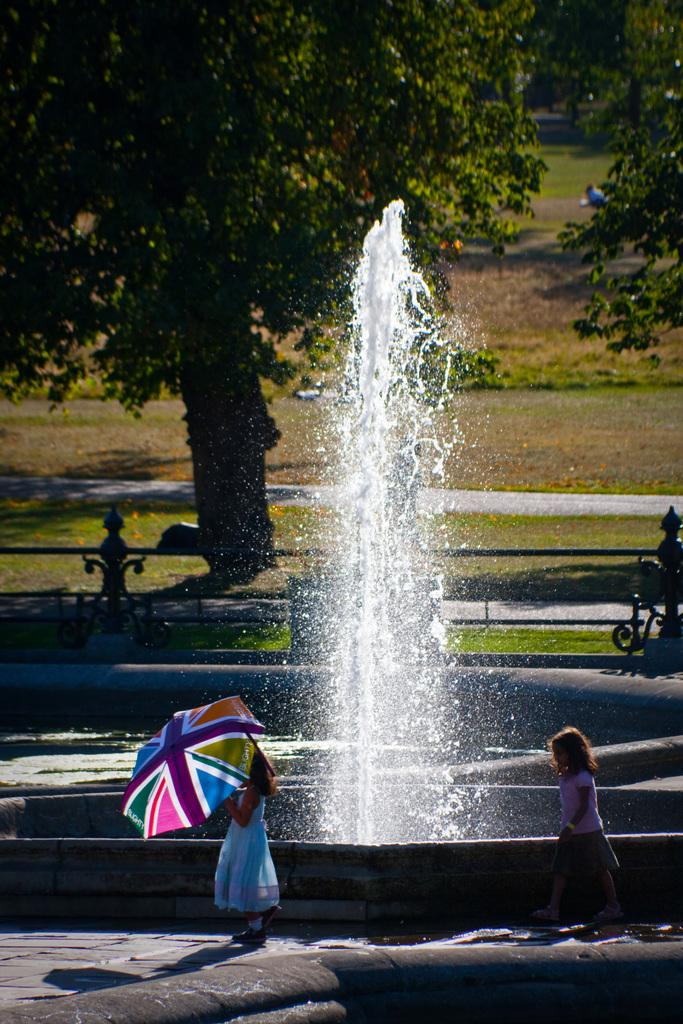What is the main feature in the middle of the image? There is a water fountain in the middle of the image. What are the two girls doing in front of the water fountain? The two girls are walking in front of the water fountain. What is the girl holding in the image? The girl is holding an umbrella. What can be seen in the background of the image? There are trees in the background of the image. What type of terrain is the grassland on? The trees are on a grassland. Where is the sofa located in the image? There is no sofa present in the image. How many ladybugs can be seen on the trees in the image? There are no ladybugs visible on the trees in the image. 